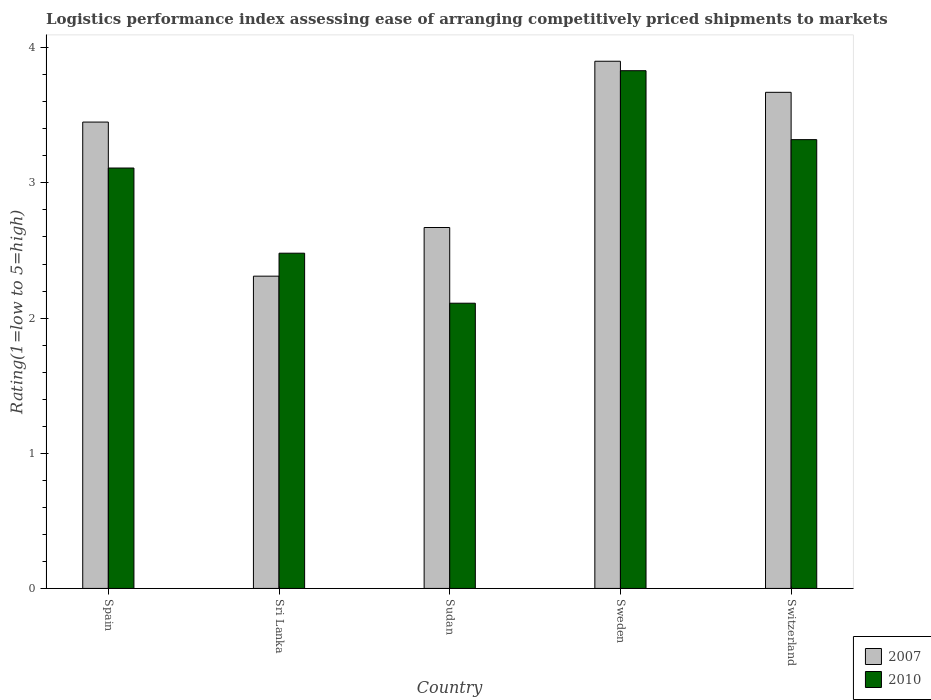How many different coloured bars are there?
Give a very brief answer. 2. Are the number of bars on each tick of the X-axis equal?
Your response must be concise. Yes. How many bars are there on the 4th tick from the right?
Offer a very short reply. 2. What is the Logistic performance index in 2007 in Sudan?
Your answer should be very brief. 2.67. Across all countries, what is the minimum Logistic performance index in 2007?
Provide a succinct answer. 2.31. In which country was the Logistic performance index in 2007 minimum?
Your answer should be compact. Sri Lanka. What is the difference between the Logistic performance index in 2010 in Spain and that in Switzerland?
Give a very brief answer. -0.21. What is the difference between the Logistic performance index in 2007 in Switzerland and the Logistic performance index in 2010 in Sudan?
Offer a terse response. 1.56. What is the average Logistic performance index in 2010 per country?
Your answer should be compact. 2.97. What is the difference between the Logistic performance index of/in 2007 and Logistic performance index of/in 2010 in Sweden?
Provide a succinct answer. 0.07. In how many countries, is the Logistic performance index in 2007 greater than 1.6?
Your answer should be compact. 5. What is the ratio of the Logistic performance index in 2007 in Sri Lanka to that in Sudan?
Give a very brief answer. 0.87. Is the difference between the Logistic performance index in 2007 in Spain and Sweden greater than the difference between the Logistic performance index in 2010 in Spain and Sweden?
Make the answer very short. Yes. What is the difference between the highest and the second highest Logistic performance index in 2007?
Your answer should be compact. -0.23. What is the difference between the highest and the lowest Logistic performance index in 2007?
Offer a very short reply. 1.59. In how many countries, is the Logistic performance index in 2007 greater than the average Logistic performance index in 2007 taken over all countries?
Offer a terse response. 3. Is the sum of the Logistic performance index in 2007 in Spain and Switzerland greater than the maximum Logistic performance index in 2010 across all countries?
Ensure brevity in your answer.  Yes. What does the 2nd bar from the left in Switzerland represents?
Make the answer very short. 2010. How many bars are there?
Your answer should be very brief. 10. Does the graph contain any zero values?
Ensure brevity in your answer.  No. Where does the legend appear in the graph?
Your answer should be compact. Bottom right. How many legend labels are there?
Offer a terse response. 2. How are the legend labels stacked?
Offer a terse response. Vertical. What is the title of the graph?
Your answer should be very brief. Logistics performance index assessing ease of arranging competitively priced shipments to markets. What is the label or title of the Y-axis?
Provide a succinct answer. Rating(1=low to 5=high). What is the Rating(1=low to 5=high) in 2007 in Spain?
Offer a terse response. 3.45. What is the Rating(1=low to 5=high) of 2010 in Spain?
Provide a short and direct response. 3.11. What is the Rating(1=low to 5=high) of 2007 in Sri Lanka?
Offer a terse response. 2.31. What is the Rating(1=low to 5=high) of 2010 in Sri Lanka?
Offer a very short reply. 2.48. What is the Rating(1=low to 5=high) of 2007 in Sudan?
Your response must be concise. 2.67. What is the Rating(1=low to 5=high) in 2010 in Sudan?
Make the answer very short. 2.11. What is the Rating(1=low to 5=high) in 2010 in Sweden?
Give a very brief answer. 3.83. What is the Rating(1=low to 5=high) of 2007 in Switzerland?
Your answer should be very brief. 3.67. What is the Rating(1=low to 5=high) of 2010 in Switzerland?
Offer a very short reply. 3.32. Across all countries, what is the maximum Rating(1=low to 5=high) in 2007?
Your response must be concise. 3.9. Across all countries, what is the maximum Rating(1=low to 5=high) in 2010?
Make the answer very short. 3.83. Across all countries, what is the minimum Rating(1=low to 5=high) of 2007?
Your answer should be very brief. 2.31. Across all countries, what is the minimum Rating(1=low to 5=high) in 2010?
Make the answer very short. 2.11. What is the total Rating(1=low to 5=high) in 2007 in the graph?
Make the answer very short. 16. What is the total Rating(1=low to 5=high) of 2010 in the graph?
Make the answer very short. 14.85. What is the difference between the Rating(1=low to 5=high) of 2007 in Spain and that in Sri Lanka?
Provide a succinct answer. 1.14. What is the difference between the Rating(1=low to 5=high) in 2010 in Spain and that in Sri Lanka?
Ensure brevity in your answer.  0.63. What is the difference between the Rating(1=low to 5=high) in 2007 in Spain and that in Sudan?
Make the answer very short. 0.78. What is the difference between the Rating(1=low to 5=high) of 2010 in Spain and that in Sudan?
Give a very brief answer. 1. What is the difference between the Rating(1=low to 5=high) of 2007 in Spain and that in Sweden?
Your answer should be very brief. -0.45. What is the difference between the Rating(1=low to 5=high) of 2010 in Spain and that in Sweden?
Your response must be concise. -0.72. What is the difference between the Rating(1=low to 5=high) of 2007 in Spain and that in Switzerland?
Keep it short and to the point. -0.22. What is the difference between the Rating(1=low to 5=high) in 2010 in Spain and that in Switzerland?
Offer a very short reply. -0.21. What is the difference between the Rating(1=low to 5=high) of 2007 in Sri Lanka and that in Sudan?
Offer a terse response. -0.36. What is the difference between the Rating(1=low to 5=high) of 2010 in Sri Lanka and that in Sudan?
Offer a very short reply. 0.37. What is the difference between the Rating(1=low to 5=high) of 2007 in Sri Lanka and that in Sweden?
Offer a terse response. -1.59. What is the difference between the Rating(1=low to 5=high) of 2010 in Sri Lanka and that in Sweden?
Provide a succinct answer. -1.35. What is the difference between the Rating(1=low to 5=high) of 2007 in Sri Lanka and that in Switzerland?
Provide a succinct answer. -1.36. What is the difference between the Rating(1=low to 5=high) of 2010 in Sri Lanka and that in Switzerland?
Your answer should be very brief. -0.84. What is the difference between the Rating(1=low to 5=high) in 2007 in Sudan and that in Sweden?
Your answer should be compact. -1.23. What is the difference between the Rating(1=low to 5=high) of 2010 in Sudan and that in Sweden?
Make the answer very short. -1.72. What is the difference between the Rating(1=low to 5=high) in 2007 in Sudan and that in Switzerland?
Ensure brevity in your answer.  -1. What is the difference between the Rating(1=low to 5=high) of 2010 in Sudan and that in Switzerland?
Provide a short and direct response. -1.21. What is the difference between the Rating(1=low to 5=high) of 2007 in Sweden and that in Switzerland?
Provide a succinct answer. 0.23. What is the difference between the Rating(1=low to 5=high) of 2010 in Sweden and that in Switzerland?
Your answer should be compact. 0.51. What is the difference between the Rating(1=low to 5=high) in 2007 in Spain and the Rating(1=low to 5=high) in 2010 in Sudan?
Provide a succinct answer. 1.34. What is the difference between the Rating(1=low to 5=high) of 2007 in Spain and the Rating(1=low to 5=high) of 2010 in Sweden?
Offer a terse response. -0.38. What is the difference between the Rating(1=low to 5=high) of 2007 in Spain and the Rating(1=low to 5=high) of 2010 in Switzerland?
Ensure brevity in your answer.  0.13. What is the difference between the Rating(1=low to 5=high) of 2007 in Sri Lanka and the Rating(1=low to 5=high) of 2010 in Sweden?
Keep it short and to the point. -1.52. What is the difference between the Rating(1=low to 5=high) in 2007 in Sri Lanka and the Rating(1=low to 5=high) in 2010 in Switzerland?
Give a very brief answer. -1.01. What is the difference between the Rating(1=low to 5=high) in 2007 in Sudan and the Rating(1=low to 5=high) in 2010 in Sweden?
Provide a short and direct response. -1.16. What is the difference between the Rating(1=low to 5=high) in 2007 in Sudan and the Rating(1=low to 5=high) in 2010 in Switzerland?
Your answer should be very brief. -0.65. What is the difference between the Rating(1=low to 5=high) in 2007 in Sweden and the Rating(1=low to 5=high) in 2010 in Switzerland?
Keep it short and to the point. 0.58. What is the average Rating(1=low to 5=high) in 2007 per country?
Provide a succinct answer. 3.2. What is the average Rating(1=low to 5=high) of 2010 per country?
Offer a very short reply. 2.97. What is the difference between the Rating(1=low to 5=high) in 2007 and Rating(1=low to 5=high) in 2010 in Spain?
Your answer should be very brief. 0.34. What is the difference between the Rating(1=low to 5=high) of 2007 and Rating(1=low to 5=high) of 2010 in Sri Lanka?
Your answer should be very brief. -0.17. What is the difference between the Rating(1=low to 5=high) of 2007 and Rating(1=low to 5=high) of 2010 in Sudan?
Provide a succinct answer. 0.56. What is the difference between the Rating(1=low to 5=high) in 2007 and Rating(1=low to 5=high) in 2010 in Sweden?
Ensure brevity in your answer.  0.07. What is the ratio of the Rating(1=low to 5=high) of 2007 in Spain to that in Sri Lanka?
Offer a very short reply. 1.49. What is the ratio of the Rating(1=low to 5=high) of 2010 in Spain to that in Sri Lanka?
Your answer should be very brief. 1.25. What is the ratio of the Rating(1=low to 5=high) in 2007 in Spain to that in Sudan?
Give a very brief answer. 1.29. What is the ratio of the Rating(1=low to 5=high) in 2010 in Spain to that in Sudan?
Make the answer very short. 1.47. What is the ratio of the Rating(1=low to 5=high) in 2007 in Spain to that in Sweden?
Offer a terse response. 0.88. What is the ratio of the Rating(1=low to 5=high) in 2010 in Spain to that in Sweden?
Your answer should be very brief. 0.81. What is the ratio of the Rating(1=low to 5=high) of 2007 in Spain to that in Switzerland?
Offer a terse response. 0.94. What is the ratio of the Rating(1=low to 5=high) of 2010 in Spain to that in Switzerland?
Provide a succinct answer. 0.94. What is the ratio of the Rating(1=low to 5=high) of 2007 in Sri Lanka to that in Sudan?
Your answer should be very brief. 0.87. What is the ratio of the Rating(1=low to 5=high) of 2010 in Sri Lanka to that in Sudan?
Your answer should be very brief. 1.18. What is the ratio of the Rating(1=low to 5=high) of 2007 in Sri Lanka to that in Sweden?
Offer a very short reply. 0.59. What is the ratio of the Rating(1=low to 5=high) in 2010 in Sri Lanka to that in Sweden?
Provide a succinct answer. 0.65. What is the ratio of the Rating(1=low to 5=high) in 2007 in Sri Lanka to that in Switzerland?
Your response must be concise. 0.63. What is the ratio of the Rating(1=low to 5=high) of 2010 in Sri Lanka to that in Switzerland?
Offer a terse response. 0.75. What is the ratio of the Rating(1=low to 5=high) in 2007 in Sudan to that in Sweden?
Give a very brief answer. 0.68. What is the ratio of the Rating(1=low to 5=high) in 2010 in Sudan to that in Sweden?
Your answer should be compact. 0.55. What is the ratio of the Rating(1=low to 5=high) of 2007 in Sudan to that in Switzerland?
Give a very brief answer. 0.73. What is the ratio of the Rating(1=low to 5=high) of 2010 in Sudan to that in Switzerland?
Your response must be concise. 0.64. What is the ratio of the Rating(1=low to 5=high) of 2007 in Sweden to that in Switzerland?
Offer a terse response. 1.06. What is the ratio of the Rating(1=low to 5=high) in 2010 in Sweden to that in Switzerland?
Your answer should be very brief. 1.15. What is the difference between the highest and the second highest Rating(1=low to 5=high) in 2007?
Offer a terse response. 0.23. What is the difference between the highest and the second highest Rating(1=low to 5=high) in 2010?
Your response must be concise. 0.51. What is the difference between the highest and the lowest Rating(1=low to 5=high) of 2007?
Offer a very short reply. 1.59. What is the difference between the highest and the lowest Rating(1=low to 5=high) in 2010?
Provide a succinct answer. 1.72. 